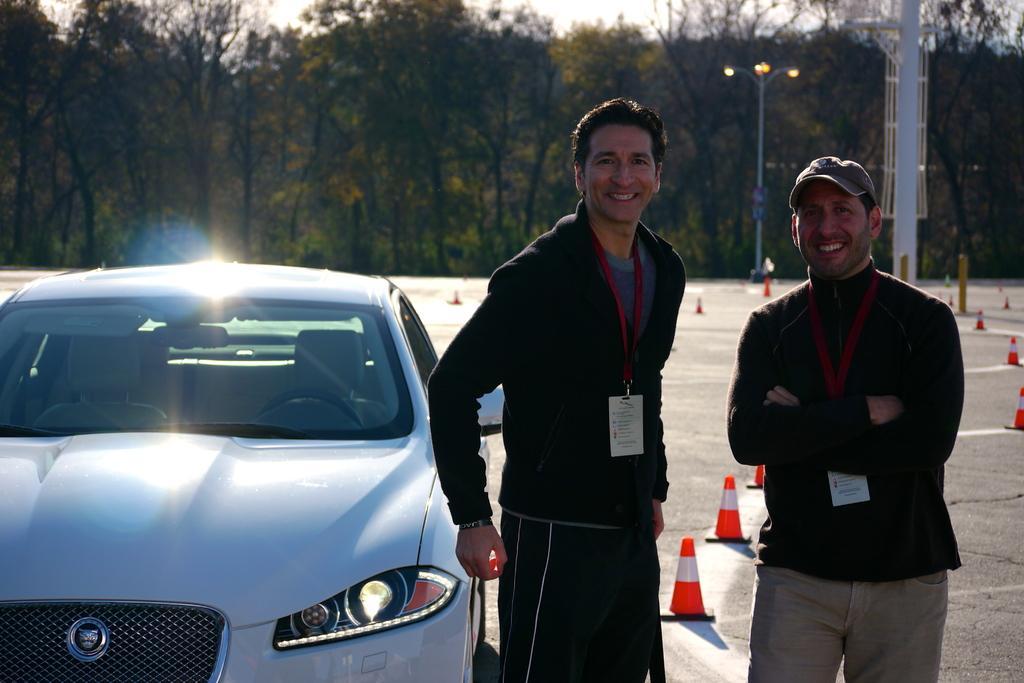Could you give a brief overview of what you see in this image? In this image we can see two men standing on the floor and they are on the right side. They are having a pretty smile on their faces and here we can see the tags on their necks. Here we can see the car on the road and it is on the left side. Here we can see the barriers on the road. Here we can see the light pole. In the background, we can see the trees. 